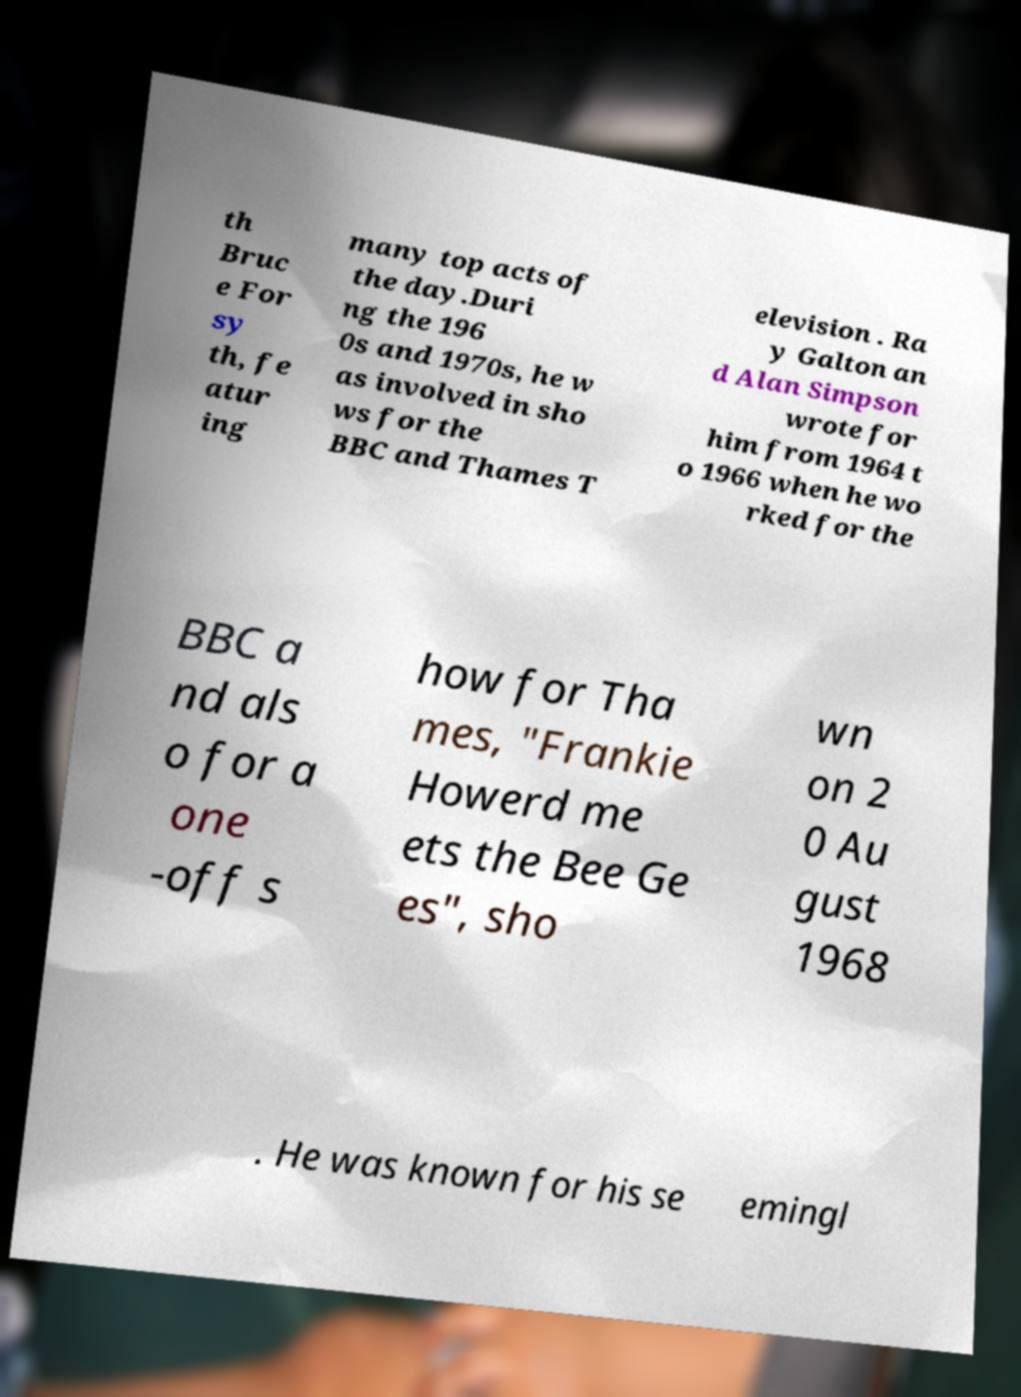I need the written content from this picture converted into text. Can you do that? th Bruc e For sy th, fe atur ing many top acts of the day.Duri ng the 196 0s and 1970s, he w as involved in sho ws for the BBC and Thames T elevision . Ra y Galton an d Alan Simpson wrote for him from 1964 t o 1966 when he wo rked for the BBC a nd als o for a one -off s how for Tha mes, "Frankie Howerd me ets the Bee Ge es", sho wn on 2 0 Au gust 1968 . He was known for his se emingl 